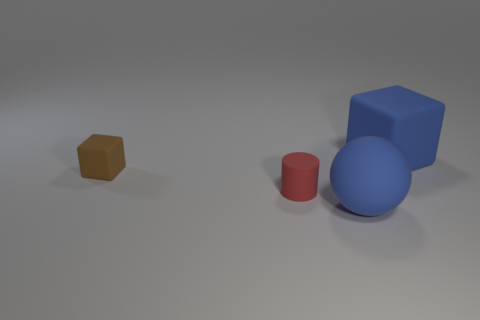Add 2 cylinders. How many objects exist? 6 Subtract all cylinders. How many objects are left? 3 Add 1 tiny green rubber cubes. How many tiny green rubber cubes exist? 1 Subtract 0 red cubes. How many objects are left? 4 Subtract all big blue objects. Subtract all large rubber objects. How many objects are left? 0 Add 4 tiny red rubber things. How many tiny red rubber things are left? 5 